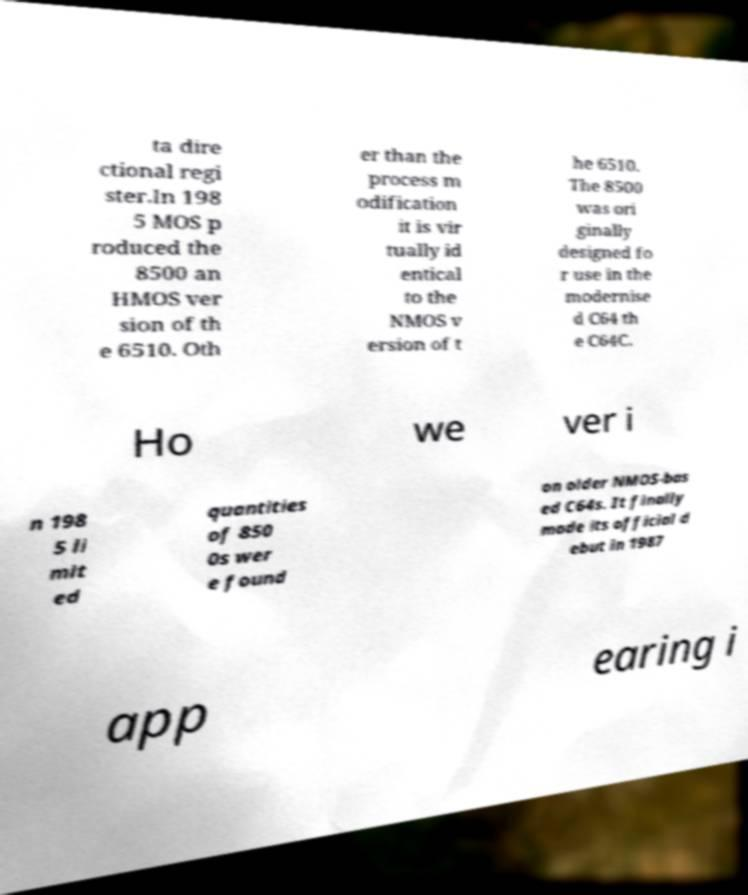Can you accurately transcribe the text from the provided image for me? ta dire ctional regi ster.In 198 5 MOS p roduced the 8500 an HMOS ver sion of th e 6510. Oth er than the process m odification it is vir tually id entical to the NMOS v ersion of t he 6510. The 8500 was ori ginally designed fo r use in the modernise d C64 th e C64C. Ho we ver i n 198 5 li mit ed quantities of 850 0s wer e found on older NMOS-bas ed C64s. It finally made its official d ebut in 1987 app earing i 